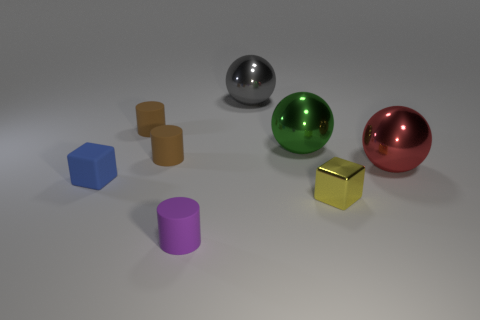Subtract all gray spheres. How many spheres are left? 2 Add 1 small blue cubes. How many objects exist? 9 Subtract all balls. How many objects are left? 5 Add 7 brown matte cylinders. How many brown matte cylinders exist? 9 Subtract 0 gray cubes. How many objects are left? 8 Subtract all gray matte blocks. Subtract all large green metallic objects. How many objects are left? 7 Add 3 small objects. How many small objects are left? 8 